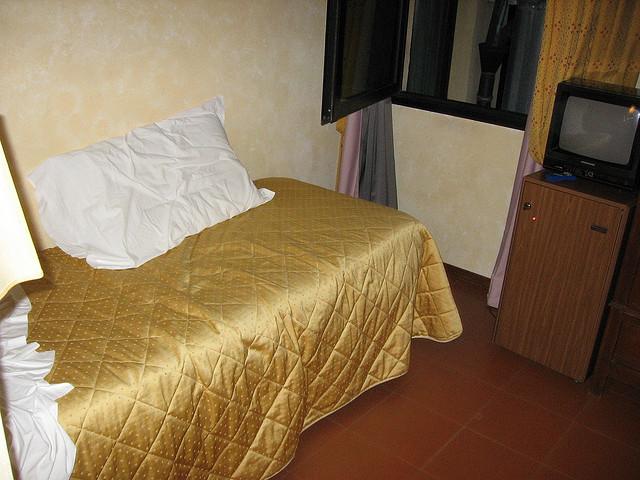Is the that a large TV?
Be succinct. No. What color is the bed cover?
Be succinct. Gold. What is the television set on?
Be succinct. Fridge. 